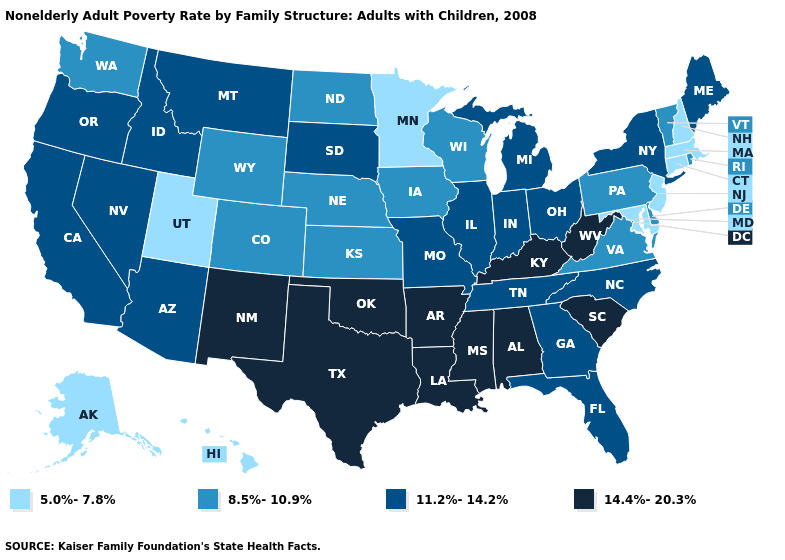Name the states that have a value in the range 14.4%-20.3%?
Write a very short answer. Alabama, Arkansas, Kentucky, Louisiana, Mississippi, New Mexico, Oklahoma, South Carolina, Texas, West Virginia. Name the states that have a value in the range 5.0%-7.8%?
Keep it brief. Alaska, Connecticut, Hawaii, Maryland, Massachusetts, Minnesota, New Hampshire, New Jersey, Utah. Does Nebraska have a higher value than South Dakota?
Keep it brief. No. Which states hav the highest value in the MidWest?
Keep it brief. Illinois, Indiana, Michigan, Missouri, Ohio, South Dakota. Name the states that have a value in the range 8.5%-10.9%?
Write a very short answer. Colorado, Delaware, Iowa, Kansas, Nebraska, North Dakota, Pennsylvania, Rhode Island, Vermont, Virginia, Washington, Wisconsin, Wyoming. Is the legend a continuous bar?
Quick response, please. No. Does Washington have the highest value in the West?
Quick response, please. No. What is the value of Ohio?
Be succinct. 11.2%-14.2%. Does the first symbol in the legend represent the smallest category?
Be succinct. Yes. What is the value of Mississippi?
Be succinct. 14.4%-20.3%. Name the states that have a value in the range 8.5%-10.9%?
Be succinct. Colorado, Delaware, Iowa, Kansas, Nebraska, North Dakota, Pennsylvania, Rhode Island, Vermont, Virginia, Washington, Wisconsin, Wyoming. What is the value of West Virginia?
Concise answer only. 14.4%-20.3%. Among the states that border Massachusetts , which have the lowest value?
Short answer required. Connecticut, New Hampshire. Among the states that border Iowa , does Missouri have the highest value?
Keep it brief. Yes. Name the states that have a value in the range 8.5%-10.9%?
Write a very short answer. Colorado, Delaware, Iowa, Kansas, Nebraska, North Dakota, Pennsylvania, Rhode Island, Vermont, Virginia, Washington, Wisconsin, Wyoming. 